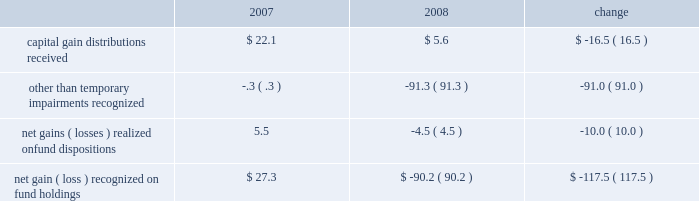Administrative fees , which increased $ 5.8 million to $ 353.9 million , are generally offset by related operating expenses that are incurred to provide services to the funds and their investors .
Our largest expense , compensation and related costs , increased $ 18.4 million or 2.3% ( 2.3 % ) from 2007 .
This increase includes $ 37.2 million in salaries resulting from an 8.4% ( 8.4 % ) increase in our average staff count and an increase of our associates 2019 base salaries at the beginning of the year .
At december 31 , 2008 , we employed 5385 associates , up 6.0% ( 6.0 % ) from the end of 2007 , primarily to add capabilities and support increased volume-related activities and other growth over the past few years .
Over the course of 2008 , we slowed the growth of our associate base from earlier plans and the prior year .
We also reduced our annual bonuses $ 27.6 million versus the 2007 year in response to unfavorable financial market conditions that negatively impacted our operating results .
The balance of the increase is attributable to higher employee benefits and employment-related expenses , including an increase of $ 5.7 million in stock-based compensation .
After higher spending during the first quarter of 2008 versus 2007 , investor sentiment in the uncertain and volatile market environment caused us to reduce advertising and promotion spending , which for the year was down $ 3.8 million from 2007 .
Occupancy and facility costs together with depreciation expense increased $ 18 million , or 12% ( 12 % ) compared to 2007 .
We expanded and renovated our facilities in 2008 to accommodate the growth in our associates to meet business demands .
Other operating expenses were up $ 3.3 million from 2007 .
We increased our spending $ 9.8 million , primarily for professional fees and information and other third-party services .
Reductions in travel and charitable contributions partially offset these increases .
Our non-operating investment activity resulted in a net loss of $ 52.3 million in 2008 as compared to a net gain of $ 80.4 million in 2007 .
This change of $ 132.7 million is primarily attributable to losses recognized in 2008 on our investments in sponsored mutual funds , which resulted from declines in financial market values during the year. .
We recognized other than temporary impairments of our investments in sponsored mutual funds because of declines in fair value below cost for an extended period .
The significant declines in fair value below cost that occurred in 2008 were generally attributable to adverse market conditions .
In addition , income from money market and bond fund holdings was $ 19.3 million lower than in 2007 due to the significantly lower interest rate environment of 2008 .
Lower interest rates also led to substantial capital appreciation on our $ 40 million holding of u.s .
Treasury notes that we sold in december 2008 at a $ 2.6 million gain .
The 2008 provision for income taxes as a percentage of pretax income is 38.4% ( 38.4 % ) , up from 37.7% ( 37.7 % ) in 2007 , primarily to reflect changes in state income tax rates and regulations and certain adjustments made prospectively based on our annual income tax return filings for 2007 .
C a p i t a l r e s o u r c e s a n d l i q u i d i t y .
During 2009 , stockholders 2019 equity increased from $ 2.5 billion to $ 2.9 billion .
We repurchased nearly 2.3 million common shares for $ 67 million in 2009 .
Tangible book value is $ 2.2 billion at december 31 , 2009 , and our cash and cash equivalents and our mutual fund investment holdings total $ 1.4 billion .
Given the availability of these financial resources , we do not maintain an available external source of liquidity .
On january 20 , 2010 , we purchased a 26% ( 26 % ) equity interest in uti asset management company and an affiliate for $ 142.4 million .
We funded the acquisition from our cash holdings .
In addition to the pending uti acquisition , we had outstanding commitments to fund other investments totaling $ 35.4 million at december 31 , 2009 .
We presently anticipate funding 2010 property and equipment expenditures of about $ 150 million from our cash balances and operating cash inflows .
22 t .
Rowe price group annual report 2009 .
What was the change in capital gain distributions received between 2007 and 2008 as a percent of the capital gain distributions received in 2007? 
Rationale: it says my value is not valid but ( 5 ) in finance means -5 .
Computations: ((16.5 * const_m1) / 22.1)
Answer: -0.74661. Administrative fees , which increased $ 5.8 million to $ 353.9 million , are generally offset by related operating expenses that are incurred to provide services to the funds and their investors .
Our largest expense , compensation and related costs , increased $ 18.4 million or 2.3% ( 2.3 % ) from 2007 .
This increase includes $ 37.2 million in salaries resulting from an 8.4% ( 8.4 % ) increase in our average staff count and an increase of our associates 2019 base salaries at the beginning of the year .
At december 31 , 2008 , we employed 5385 associates , up 6.0% ( 6.0 % ) from the end of 2007 , primarily to add capabilities and support increased volume-related activities and other growth over the past few years .
Over the course of 2008 , we slowed the growth of our associate base from earlier plans and the prior year .
We also reduced our annual bonuses $ 27.6 million versus the 2007 year in response to unfavorable financial market conditions that negatively impacted our operating results .
The balance of the increase is attributable to higher employee benefits and employment-related expenses , including an increase of $ 5.7 million in stock-based compensation .
After higher spending during the first quarter of 2008 versus 2007 , investor sentiment in the uncertain and volatile market environment caused us to reduce advertising and promotion spending , which for the year was down $ 3.8 million from 2007 .
Occupancy and facility costs together with depreciation expense increased $ 18 million , or 12% ( 12 % ) compared to 2007 .
We expanded and renovated our facilities in 2008 to accommodate the growth in our associates to meet business demands .
Other operating expenses were up $ 3.3 million from 2007 .
We increased our spending $ 9.8 million , primarily for professional fees and information and other third-party services .
Reductions in travel and charitable contributions partially offset these increases .
Our non-operating investment activity resulted in a net loss of $ 52.3 million in 2008 as compared to a net gain of $ 80.4 million in 2007 .
This change of $ 132.7 million is primarily attributable to losses recognized in 2008 on our investments in sponsored mutual funds , which resulted from declines in financial market values during the year. .
We recognized other than temporary impairments of our investments in sponsored mutual funds because of declines in fair value below cost for an extended period .
The significant declines in fair value below cost that occurred in 2008 were generally attributable to adverse market conditions .
In addition , income from money market and bond fund holdings was $ 19.3 million lower than in 2007 due to the significantly lower interest rate environment of 2008 .
Lower interest rates also led to substantial capital appreciation on our $ 40 million holding of u.s .
Treasury notes that we sold in december 2008 at a $ 2.6 million gain .
The 2008 provision for income taxes as a percentage of pretax income is 38.4% ( 38.4 % ) , up from 37.7% ( 37.7 % ) in 2007 , primarily to reflect changes in state income tax rates and regulations and certain adjustments made prospectively based on our annual income tax return filings for 2007 .
C a p i t a l r e s o u r c e s a n d l i q u i d i t y .
During 2009 , stockholders 2019 equity increased from $ 2.5 billion to $ 2.9 billion .
We repurchased nearly 2.3 million common shares for $ 67 million in 2009 .
Tangible book value is $ 2.2 billion at december 31 , 2009 , and our cash and cash equivalents and our mutual fund investment holdings total $ 1.4 billion .
Given the availability of these financial resources , we do not maintain an available external source of liquidity .
On january 20 , 2010 , we purchased a 26% ( 26 % ) equity interest in uti asset management company and an affiliate for $ 142.4 million .
We funded the acquisition from our cash holdings .
In addition to the pending uti acquisition , we had outstanding commitments to fund other investments totaling $ 35.4 million at december 31 , 2009 .
We presently anticipate funding 2010 property and equipment expenditures of about $ 150 million from our cash balances and operating cash inflows .
22 t .
Rowe price group annual report 2009 .
What is the total enterprise value in millions of uti asset management company and affiliate at the price paid for the 26% ( 26 % ) stake? 
Computations: (142.4 / 26%)
Answer: 547.69231. 